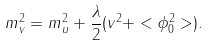Convert formula to latex. <formula><loc_0><loc_0><loc_500><loc_500>m _ { v } ^ { 2 } = m _ { u } ^ { 2 } + \frac { \lambda } { 2 } ( v ^ { 2 } + < \phi _ { 0 } ^ { 2 } > ) .</formula> 